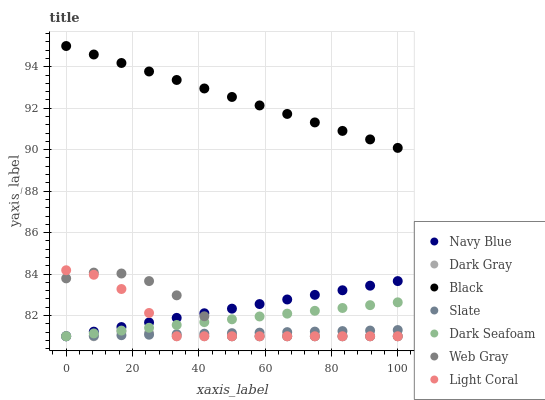Does Dark Gray have the minimum area under the curve?
Answer yes or no. Yes. Does Black have the maximum area under the curve?
Answer yes or no. Yes. Does Web Gray have the minimum area under the curve?
Answer yes or no. No. Does Web Gray have the maximum area under the curve?
Answer yes or no. No. Is Slate the smoothest?
Answer yes or no. Yes. Is Web Gray the roughest?
Answer yes or no. Yes. Is Navy Blue the smoothest?
Answer yes or no. No. Is Navy Blue the roughest?
Answer yes or no. No. Does Light Coral have the lowest value?
Answer yes or no. Yes. Does Black have the lowest value?
Answer yes or no. No. Does Black have the highest value?
Answer yes or no. Yes. Does Web Gray have the highest value?
Answer yes or no. No. Is Light Coral less than Black?
Answer yes or no. Yes. Is Black greater than Navy Blue?
Answer yes or no. Yes. Does Light Coral intersect Dark Seafoam?
Answer yes or no. Yes. Is Light Coral less than Dark Seafoam?
Answer yes or no. No. Is Light Coral greater than Dark Seafoam?
Answer yes or no. No. Does Light Coral intersect Black?
Answer yes or no. No. 